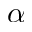<formula> <loc_0><loc_0><loc_500><loc_500>\alpha</formula> 